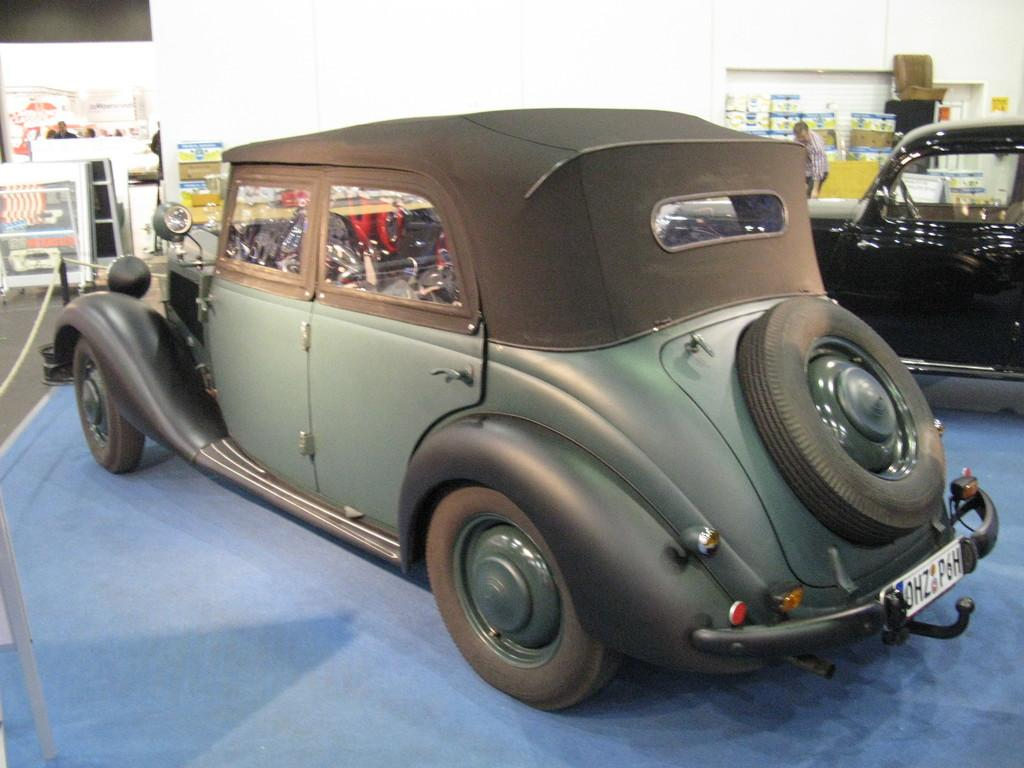How many cars are present in the image? There are two cars in the image. What can be seen in the background of the image? There is a wall in the background of the image. What color is the floor at the bottom of the image? The floor at the bottom of the image is blue in color. Is there a brother playing with a creature in the garden in the image? There is no garden, brother, or creature present in the image. 